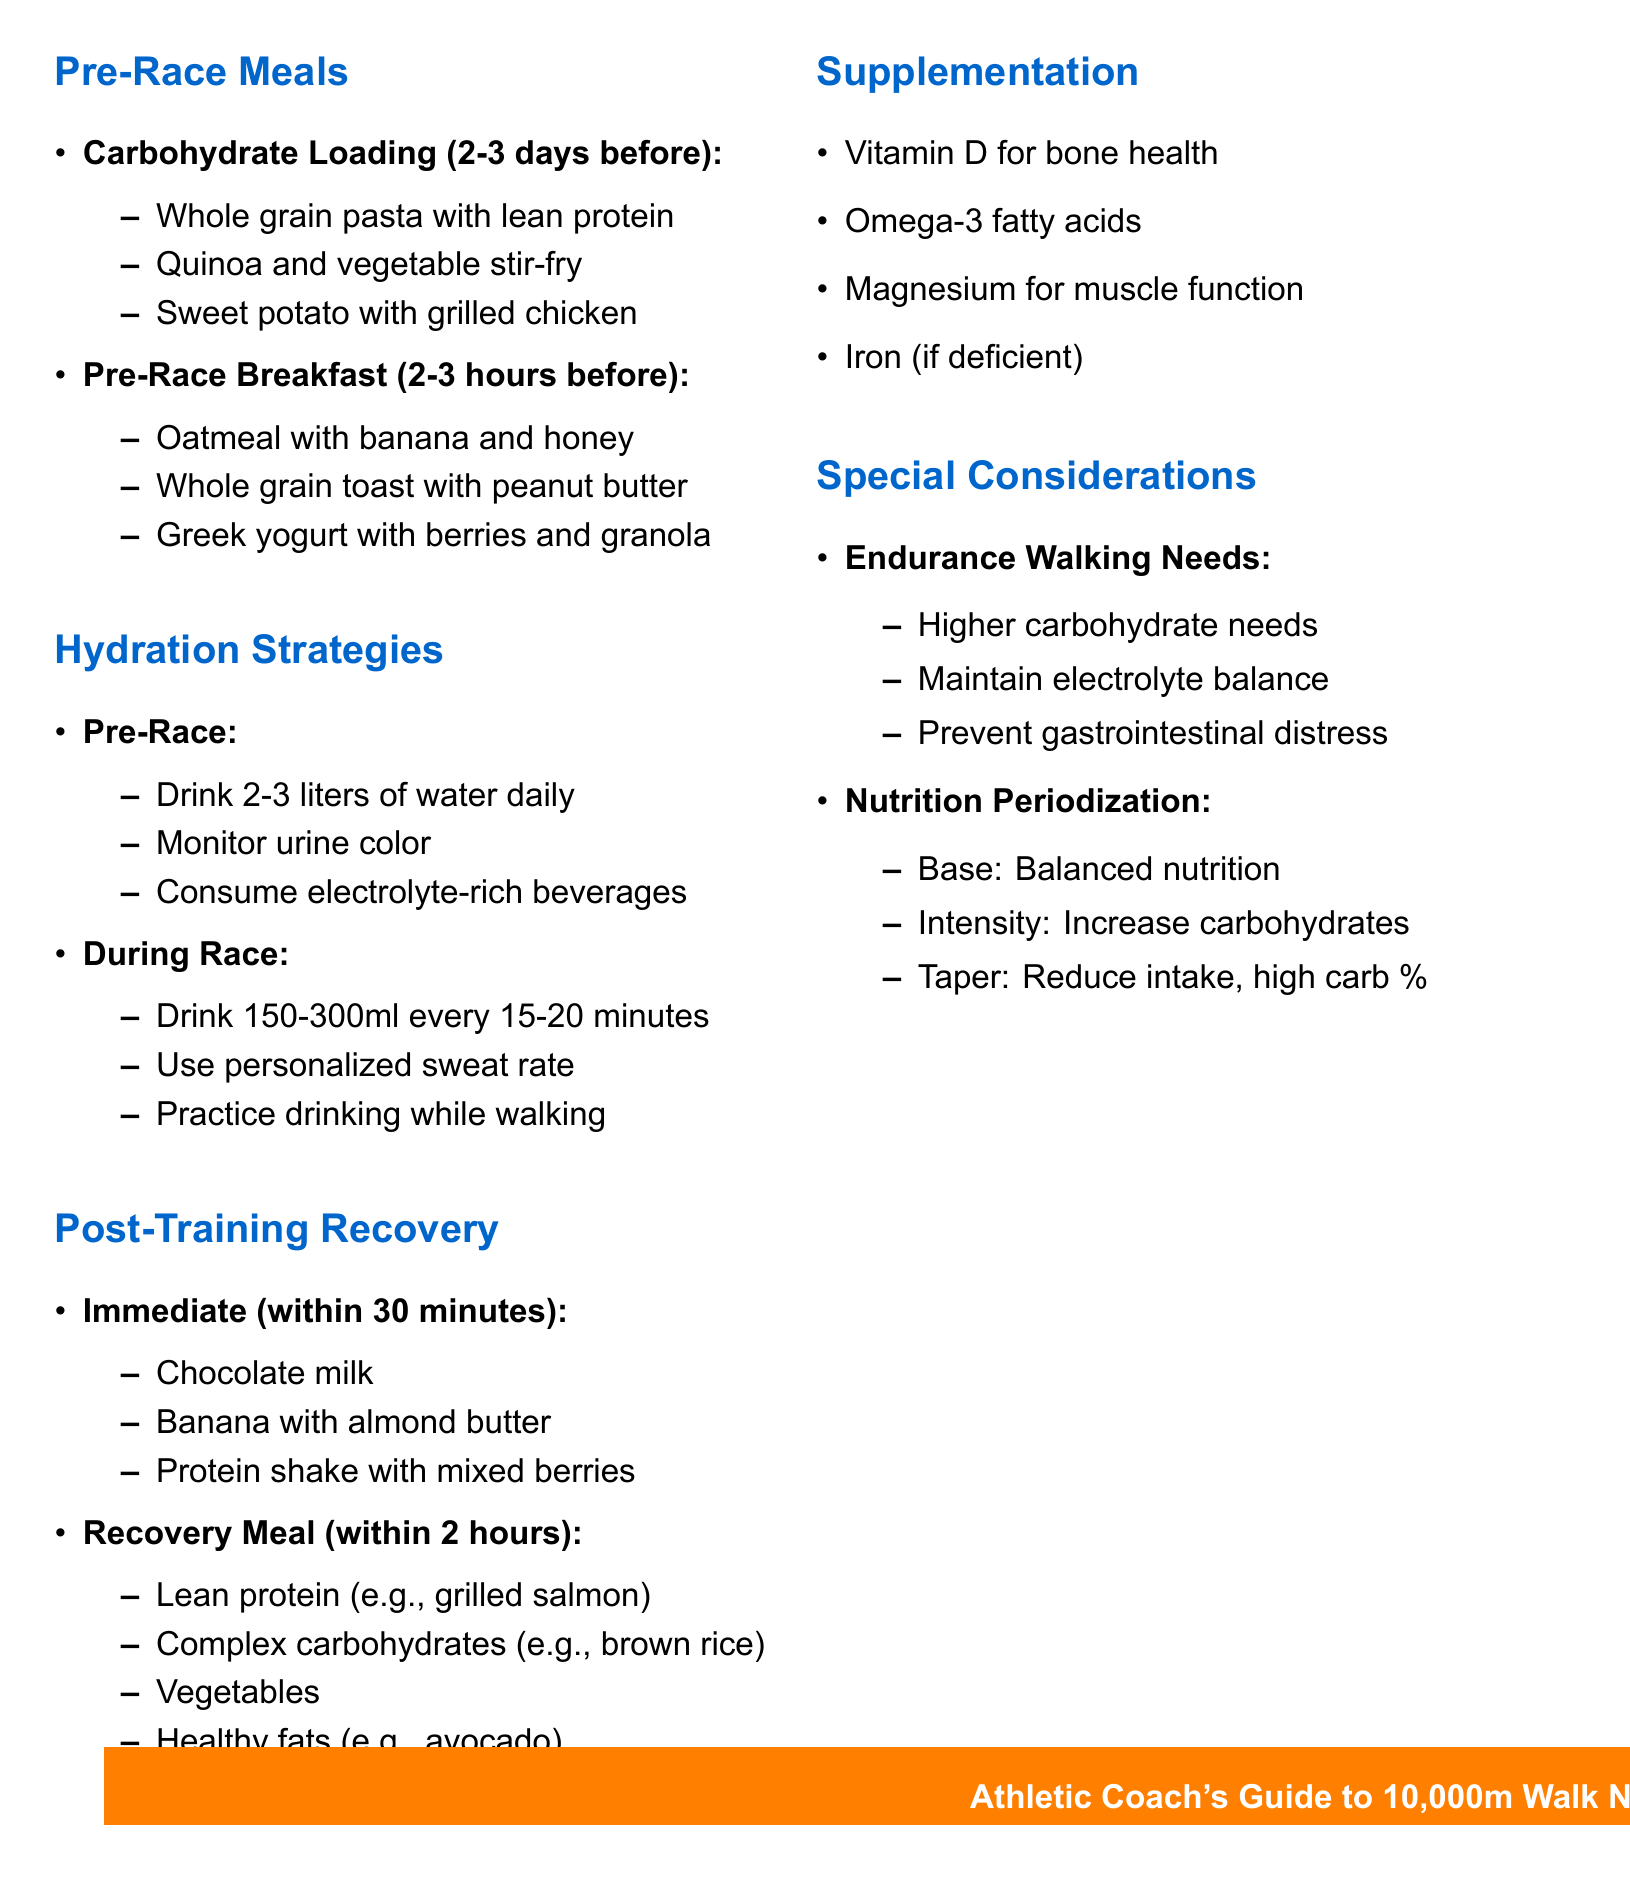What is the pre-race meal for carbohydrate loading? The pre-race meal for carbohydrate loading should increase carbohydrate intake 2-3 days before the race, with suggested meals like whole grain pasta with lean protein.
Answer: Whole grain pasta with lean protein How many liters of water should be consumed daily before the race? The document states that 2-3 liters of water should be consumed daily for proper hydration in the days leading up to the race.
Answer: 2-3 liters What is a recommended immediate post-training food? The document lists several immediate post-training foods, one of which is chocolate milk.
Answer: Chocolate milk What should a recovery meal contain? A recovery meal should include lean protein, complex carbohydrates, vegetables, and healthy fats, according to the document.
Answer: Lean protein, complex carbohydrates, vegetables, healthy fats Which supplement is mentioned for inflammation reduction? The document specifies omega-3 fatty acids as one of the key supplements to support performance and recovery, particularly for inflammation reduction.
Answer: Omega-3 fatty acids What is a strategy to prevent gastrointestinal distress during long walks? The document mentions maintaining electrolyte balance as a strategy to prevent gastrointestinal distress during long walks.
Answer: Maintain electrolyte balance How long before the event should the pre-race breakfast be consumed? According to the document, the pre-race breakfast should be consumed 2-3 hours before the event.
Answer: 2-3 hours What should athletes monitor to ensure proper hydration? The document states that athletes should monitor urine color to ensure proper hydration, with pale yellow indicating good hydration.
Answer: Urine color In the intensity phase of nutrition periodization, what should athletes increase? The document indicates that in the intensity phase, athletes should increase carbohydrate intake.
Answer: Carbohydrate intake What is the purpose of consuming foods immediately after training? The document explains that consuming foods immediately after training helps to replenish glycogen and aid muscle recovery.
Answer: Replenish glycogen and aid muscle recovery 